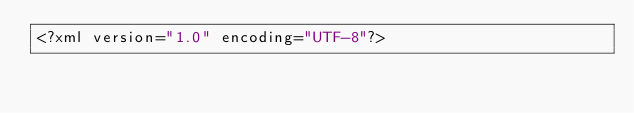Convert code to text. <code><loc_0><loc_0><loc_500><loc_500><_XML_><?xml version="1.0" encoding="UTF-8"?></code> 